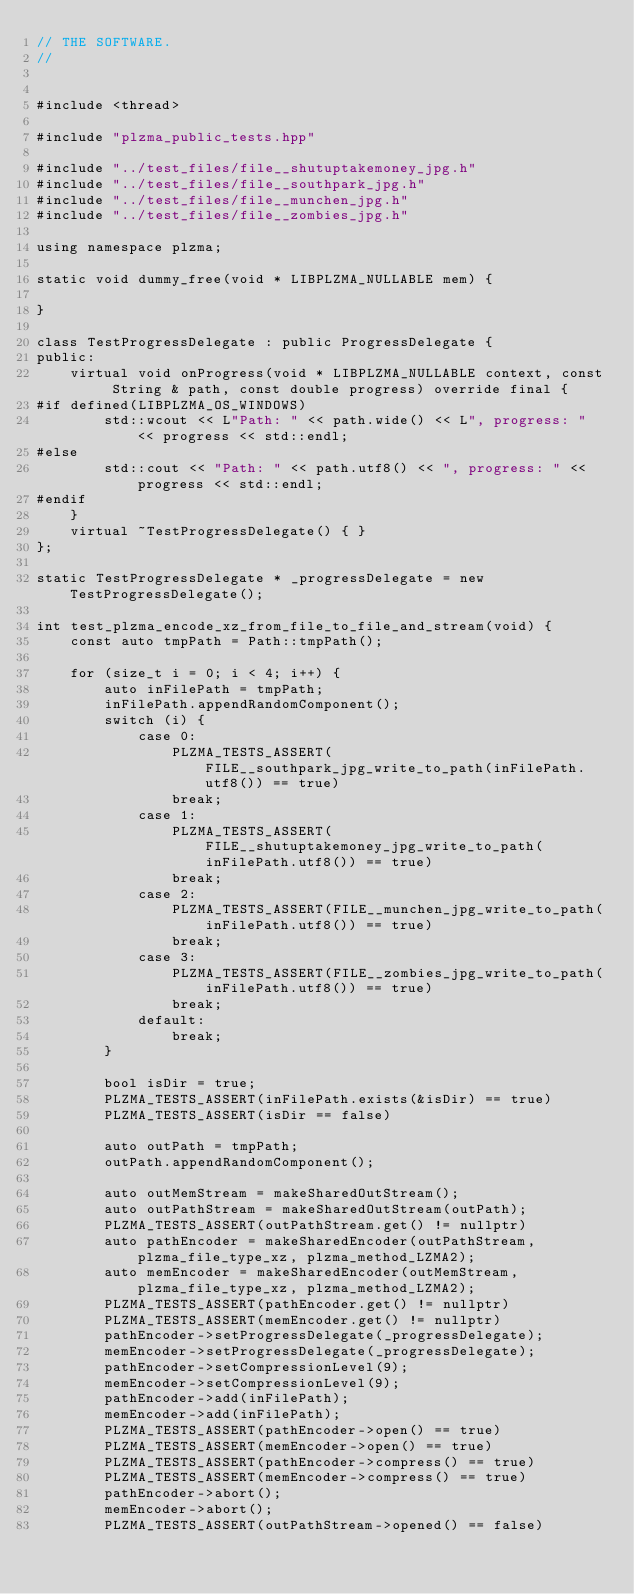<code> <loc_0><loc_0><loc_500><loc_500><_C++_>// THE SOFTWARE.
//


#include <thread>

#include "plzma_public_tests.hpp"

#include "../test_files/file__shutuptakemoney_jpg.h"
#include "../test_files/file__southpark_jpg.h"
#include "../test_files/file__munchen_jpg.h"
#include "../test_files/file__zombies_jpg.h"

using namespace plzma;

static void dummy_free(void * LIBPLZMA_NULLABLE mem) {
    
}

class TestProgressDelegate : public ProgressDelegate {
public:
    virtual void onProgress(void * LIBPLZMA_NULLABLE context, const String & path, const double progress) override final {
#if defined(LIBPLZMA_OS_WINDOWS)
        std::wcout << L"Path: " << path.wide() << L", progress: " << progress << std::endl;
#else
        std::cout << "Path: " << path.utf8() << ", progress: " << progress << std::endl;
#endif
    }
    virtual ~TestProgressDelegate() { }
};

static TestProgressDelegate * _progressDelegate = new TestProgressDelegate();

int test_plzma_encode_xz_from_file_to_file_and_stream(void) {
    const auto tmpPath = Path::tmpPath();
    
    for (size_t i = 0; i < 4; i++) {
        auto inFilePath = tmpPath;
        inFilePath.appendRandomComponent();
        switch (i) {
            case 0:
                PLZMA_TESTS_ASSERT(FILE__southpark_jpg_write_to_path(inFilePath.utf8()) == true)
                break;
            case 1:
                PLZMA_TESTS_ASSERT(FILE__shutuptakemoney_jpg_write_to_path(inFilePath.utf8()) == true)
                break;
            case 2:
                PLZMA_TESTS_ASSERT(FILE__munchen_jpg_write_to_path(inFilePath.utf8()) == true)
                break;
            case 3:
                PLZMA_TESTS_ASSERT(FILE__zombies_jpg_write_to_path(inFilePath.utf8()) == true)
                break;
            default:
                break;
        }
        
        bool isDir = true;
        PLZMA_TESTS_ASSERT(inFilePath.exists(&isDir) == true)
        PLZMA_TESTS_ASSERT(isDir == false)
        
        auto outPath = tmpPath;
        outPath.appendRandomComponent();
        
        auto outMemStream = makeSharedOutStream();
        auto outPathStream = makeSharedOutStream(outPath);
        PLZMA_TESTS_ASSERT(outPathStream.get() != nullptr)
        auto pathEncoder = makeSharedEncoder(outPathStream, plzma_file_type_xz, plzma_method_LZMA2);
        auto memEncoder = makeSharedEncoder(outMemStream, plzma_file_type_xz, plzma_method_LZMA2);
        PLZMA_TESTS_ASSERT(pathEncoder.get() != nullptr)
        PLZMA_TESTS_ASSERT(memEncoder.get() != nullptr)
        pathEncoder->setProgressDelegate(_progressDelegate);
        memEncoder->setProgressDelegate(_progressDelegate);
        pathEncoder->setCompressionLevel(9);
        memEncoder->setCompressionLevel(9);
        pathEncoder->add(inFilePath);
        memEncoder->add(inFilePath);
        PLZMA_TESTS_ASSERT(pathEncoder->open() == true)
        PLZMA_TESTS_ASSERT(memEncoder->open() == true)
        PLZMA_TESTS_ASSERT(pathEncoder->compress() == true)
        PLZMA_TESTS_ASSERT(memEncoder->compress() == true)
        pathEncoder->abort();
        memEncoder->abort();
        PLZMA_TESTS_ASSERT(outPathStream->opened() == false)</code> 